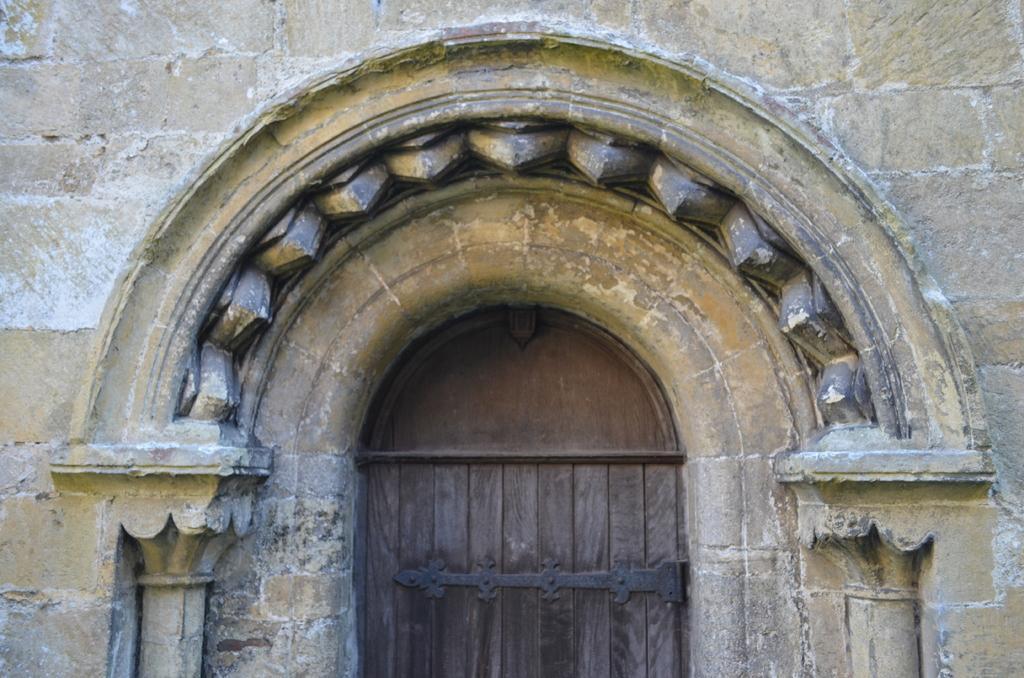Could you give a brief overview of what you see in this image? In this image we can see door to the building. 